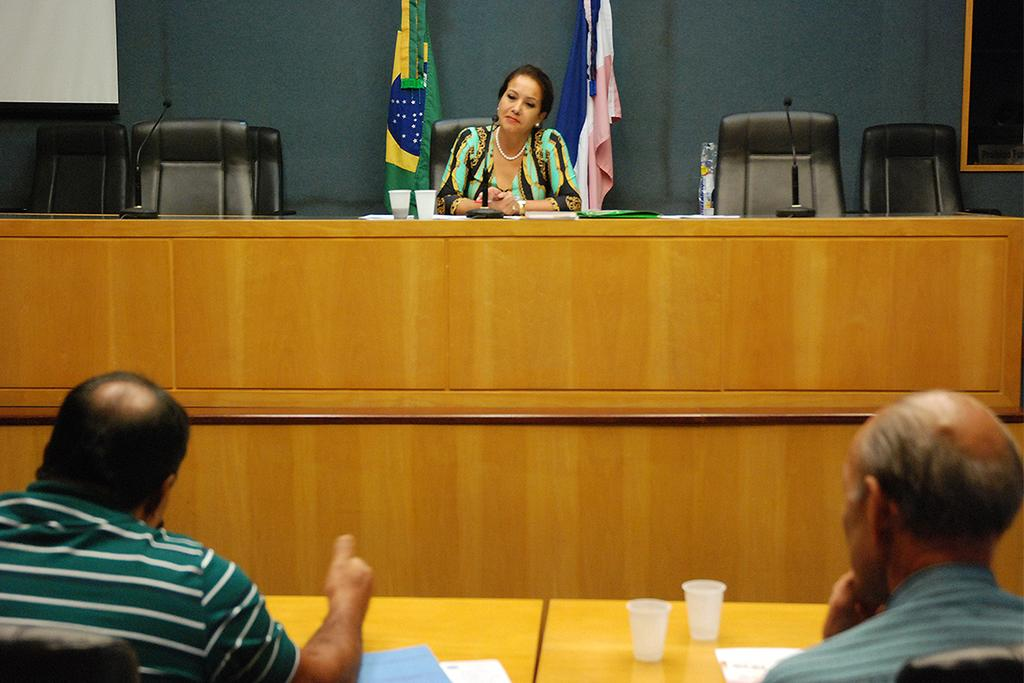How many people are in the room? There are 3 people in the room. What are the people doing in the room? The people are sitting on chairs. What objects can be seen on the table? There are glasses, a microphone, and papers on the table. What can be seen in the background of the room? There are 2 flags and a wall in the background. What does the mom say to the people sitting on chairs? There is no mention of a mom or any spoken words in the image, so it is not possible to answer that question. 